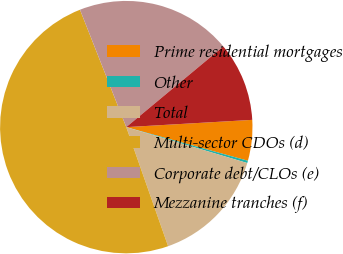Convert chart. <chart><loc_0><loc_0><loc_500><loc_500><pie_chart><fcel>Prime residential mortgages<fcel>Other<fcel>Total<fcel>Multi-sector CDOs (d)<fcel>Corporate debt/CLOs (e)<fcel>Mezzanine tranches (f)<nl><fcel>5.21%<fcel>0.3%<fcel>15.03%<fcel>49.4%<fcel>19.94%<fcel>10.12%<nl></chart> 